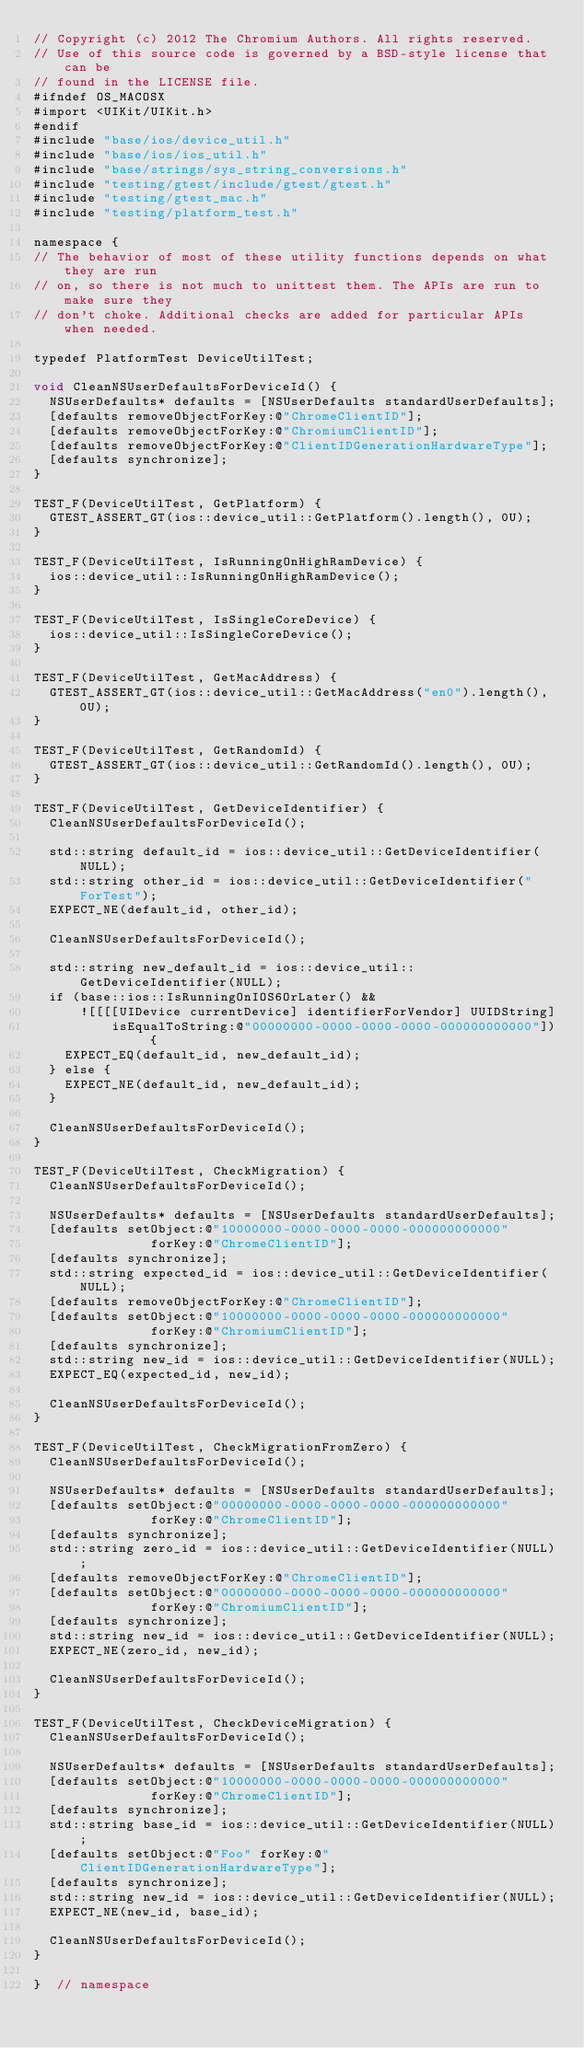Convert code to text. <code><loc_0><loc_0><loc_500><loc_500><_ObjectiveC_>// Copyright (c) 2012 The Chromium Authors. All rights reserved.
// Use of this source code is governed by a BSD-style license that can be
// found in the LICENSE file.
#ifndef OS_MACOSX
#import <UIKit/UIKit.h>
#endif
#include "base/ios/device_util.h"
#include "base/ios/ios_util.h"
#include "base/strings/sys_string_conversions.h"
#include "testing/gtest/include/gtest/gtest.h"
#include "testing/gtest_mac.h"
#include "testing/platform_test.h"

namespace {
// The behavior of most of these utility functions depends on what they are run
// on, so there is not much to unittest them. The APIs are run to make sure they
// don't choke. Additional checks are added for particular APIs when needed.

typedef PlatformTest DeviceUtilTest;

void CleanNSUserDefaultsForDeviceId() {
  NSUserDefaults* defaults = [NSUserDefaults standardUserDefaults];
  [defaults removeObjectForKey:@"ChromeClientID"];
  [defaults removeObjectForKey:@"ChromiumClientID"];
  [defaults removeObjectForKey:@"ClientIDGenerationHardwareType"];
  [defaults synchronize];
}

TEST_F(DeviceUtilTest, GetPlatform) {
  GTEST_ASSERT_GT(ios::device_util::GetPlatform().length(), 0U);
}

TEST_F(DeviceUtilTest, IsRunningOnHighRamDevice) {
  ios::device_util::IsRunningOnHighRamDevice();
}

TEST_F(DeviceUtilTest, IsSingleCoreDevice) {
  ios::device_util::IsSingleCoreDevice();
}

TEST_F(DeviceUtilTest, GetMacAddress) {
  GTEST_ASSERT_GT(ios::device_util::GetMacAddress("en0").length(), 0U);
}

TEST_F(DeviceUtilTest, GetRandomId) {
  GTEST_ASSERT_GT(ios::device_util::GetRandomId().length(), 0U);
}

TEST_F(DeviceUtilTest, GetDeviceIdentifier) {
  CleanNSUserDefaultsForDeviceId();

  std::string default_id = ios::device_util::GetDeviceIdentifier(NULL);
  std::string other_id = ios::device_util::GetDeviceIdentifier("ForTest");
  EXPECT_NE(default_id, other_id);

  CleanNSUserDefaultsForDeviceId();

  std::string new_default_id = ios::device_util::GetDeviceIdentifier(NULL);
  if (base::ios::IsRunningOnIOS6OrLater() &&
      ![[[[UIDevice currentDevice] identifierForVendor] UUIDString]
          isEqualToString:@"00000000-0000-0000-0000-000000000000"]) {
    EXPECT_EQ(default_id, new_default_id);
  } else {
    EXPECT_NE(default_id, new_default_id);
  }

  CleanNSUserDefaultsForDeviceId();
}

TEST_F(DeviceUtilTest, CheckMigration) {
  CleanNSUserDefaultsForDeviceId();

  NSUserDefaults* defaults = [NSUserDefaults standardUserDefaults];
  [defaults setObject:@"10000000-0000-0000-0000-000000000000"
               forKey:@"ChromeClientID"];
  [defaults synchronize];
  std::string expected_id = ios::device_util::GetDeviceIdentifier(NULL);
  [defaults removeObjectForKey:@"ChromeClientID"];
  [defaults setObject:@"10000000-0000-0000-0000-000000000000"
               forKey:@"ChromiumClientID"];
  [defaults synchronize];
  std::string new_id = ios::device_util::GetDeviceIdentifier(NULL);
  EXPECT_EQ(expected_id, new_id);

  CleanNSUserDefaultsForDeviceId();
}

TEST_F(DeviceUtilTest, CheckMigrationFromZero) {
  CleanNSUserDefaultsForDeviceId();

  NSUserDefaults* defaults = [NSUserDefaults standardUserDefaults];
  [defaults setObject:@"00000000-0000-0000-0000-000000000000"
               forKey:@"ChromeClientID"];
  [defaults synchronize];
  std::string zero_id = ios::device_util::GetDeviceIdentifier(NULL);
  [defaults removeObjectForKey:@"ChromeClientID"];
  [defaults setObject:@"00000000-0000-0000-0000-000000000000"
               forKey:@"ChromiumClientID"];
  [defaults synchronize];
  std::string new_id = ios::device_util::GetDeviceIdentifier(NULL);
  EXPECT_NE(zero_id, new_id);

  CleanNSUserDefaultsForDeviceId();
}

TEST_F(DeviceUtilTest, CheckDeviceMigration) {
  CleanNSUserDefaultsForDeviceId();

  NSUserDefaults* defaults = [NSUserDefaults standardUserDefaults];
  [defaults setObject:@"10000000-0000-0000-0000-000000000000"
               forKey:@"ChromeClientID"];
  [defaults synchronize];
  std::string base_id = ios::device_util::GetDeviceIdentifier(NULL);
  [defaults setObject:@"Foo" forKey:@"ClientIDGenerationHardwareType"];
  [defaults synchronize];
  std::string new_id = ios::device_util::GetDeviceIdentifier(NULL);
  EXPECT_NE(new_id, base_id);

  CleanNSUserDefaultsForDeviceId();
}

}  // namespace
</code> 